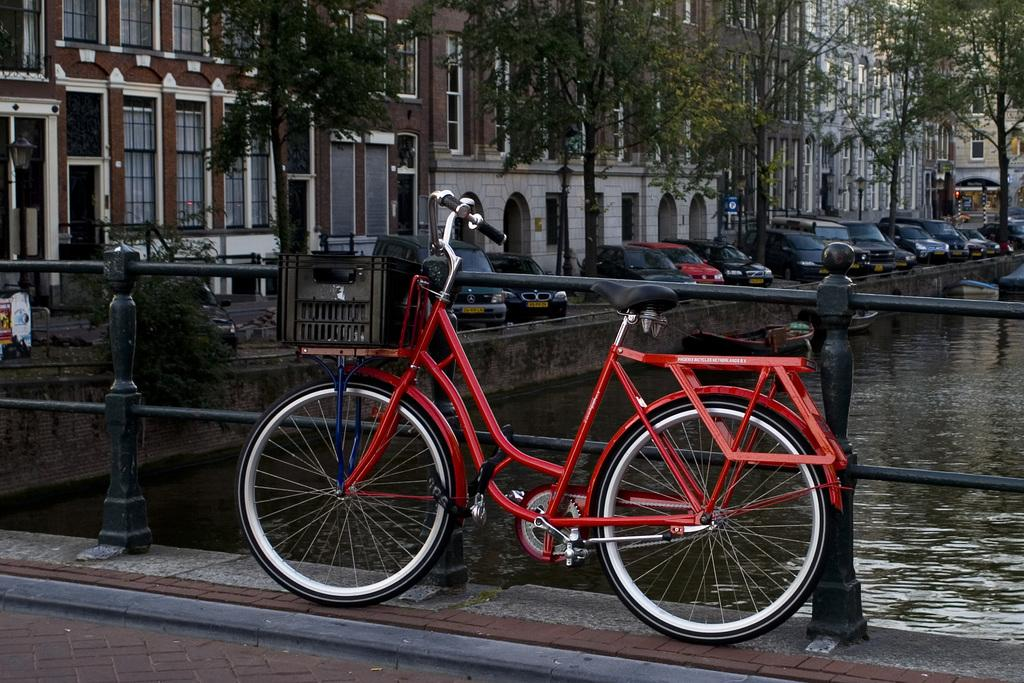What type of structures can be seen in the background of the image? There are buildings in the background of the image. What can be seen through the windows visible in the image? The presence of windows suggests that there might be a view of the surroundings, but the specific view cannot be determined from the facts provided. What type of vertical structures are present in the image? There are poles in the image. What is the purpose of the board in the image? The purpose of the board cannot be determined from the facts provided. What type of vehicles are present in the image? There are cars in the image. What type of barrier is present in the image? There is a railing in the image. What type of transportation is present in the image? There is a bicycle in the image. What type of watercraft is present in the image? There are boats in the image. What type of natural feature is visible in the image? There is water visible in the image. What type of creature is holding the bicycle in the image? There is no creature present in the image; it is a bicycle without any visible rider. How much wealth is visible in the image? The concept of wealth is not applicable to the objects and structures visible in the image. 